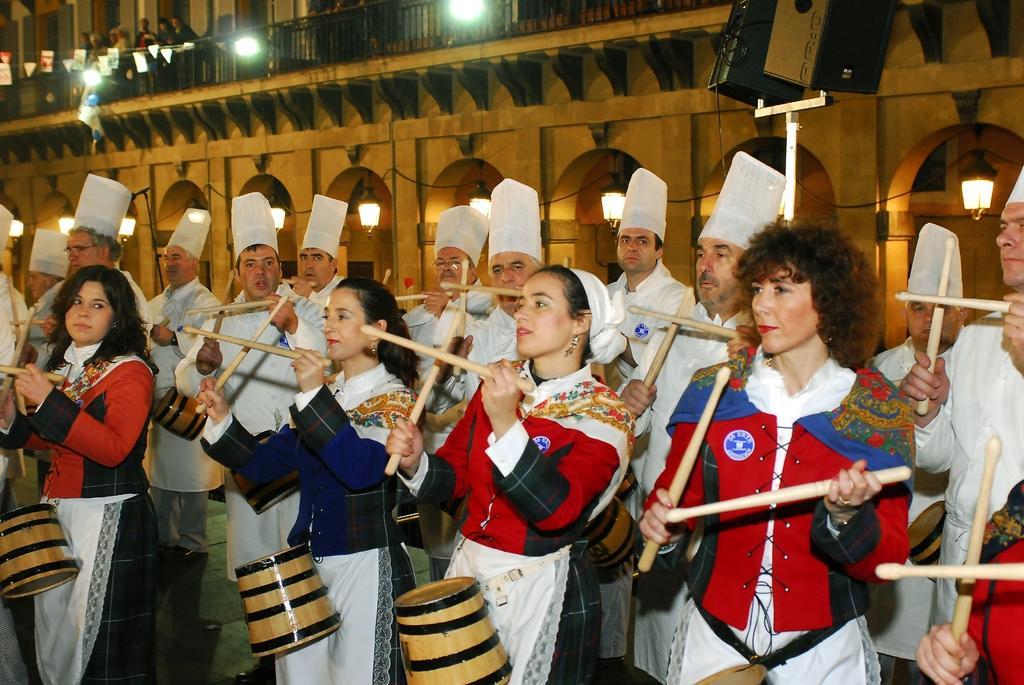Could you give a brief overview of what you see in this image? This is a picture in which we can a group of people holding some sticks and the men have white color cap on their head and some lights and behind there is a building on which the people are standing. 